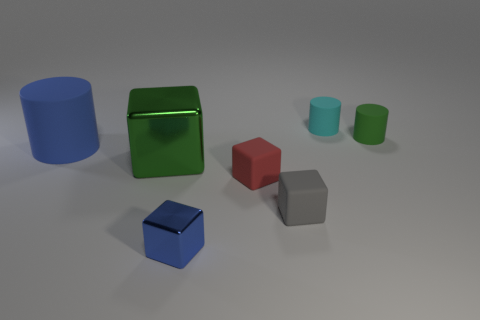Are there any matte objects of the same color as the big metallic object?
Your answer should be compact. Yes. Is the color of the small shiny cube the same as the cylinder that is to the left of the cyan rubber cylinder?
Your answer should be very brief. Yes. The thing that is the same color as the large rubber cylinder is what shape?
Offer a very short reply. Cube. Is the tiny metal block the same color as the big rubber object?
Offer a very short reply. Yes. Do the tiny block that is on the left side of the red rubber cube and the large metal cube have the same color?
Make the answer very short. No. Are there any other things of the same color as the large cube?
Give a very brief answer. Yes. Are there more matte objects that are to the left of the tiny red matte block than large brown rubber cubes?
Make the answer very short. Yes. Is the blue matte object the same size as the cyan rubber thing?
Ensure brevity in your answer.  No. There is a tiny blue object that is the same shape as the gray matte object; what is its material?
Offer a terse response. Metal. Are there any other things that are made of the same material as the big green block?
Provide a succinct answer. Yes. 